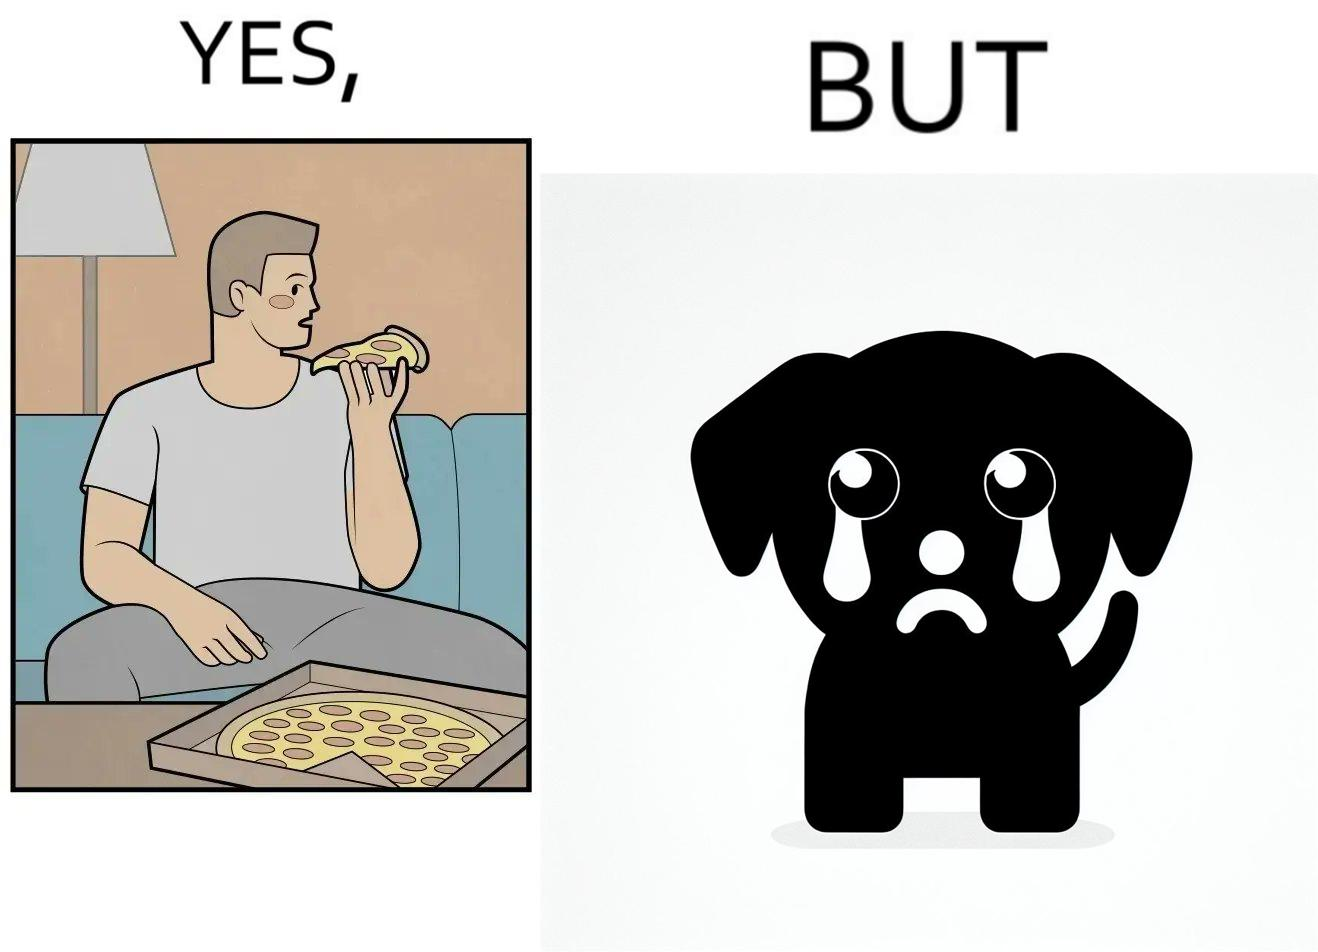Is there satirical content in this image? Yes, this image is satirical. 